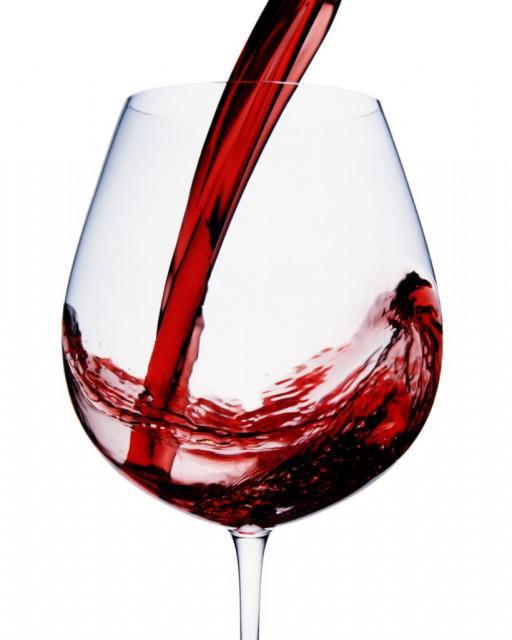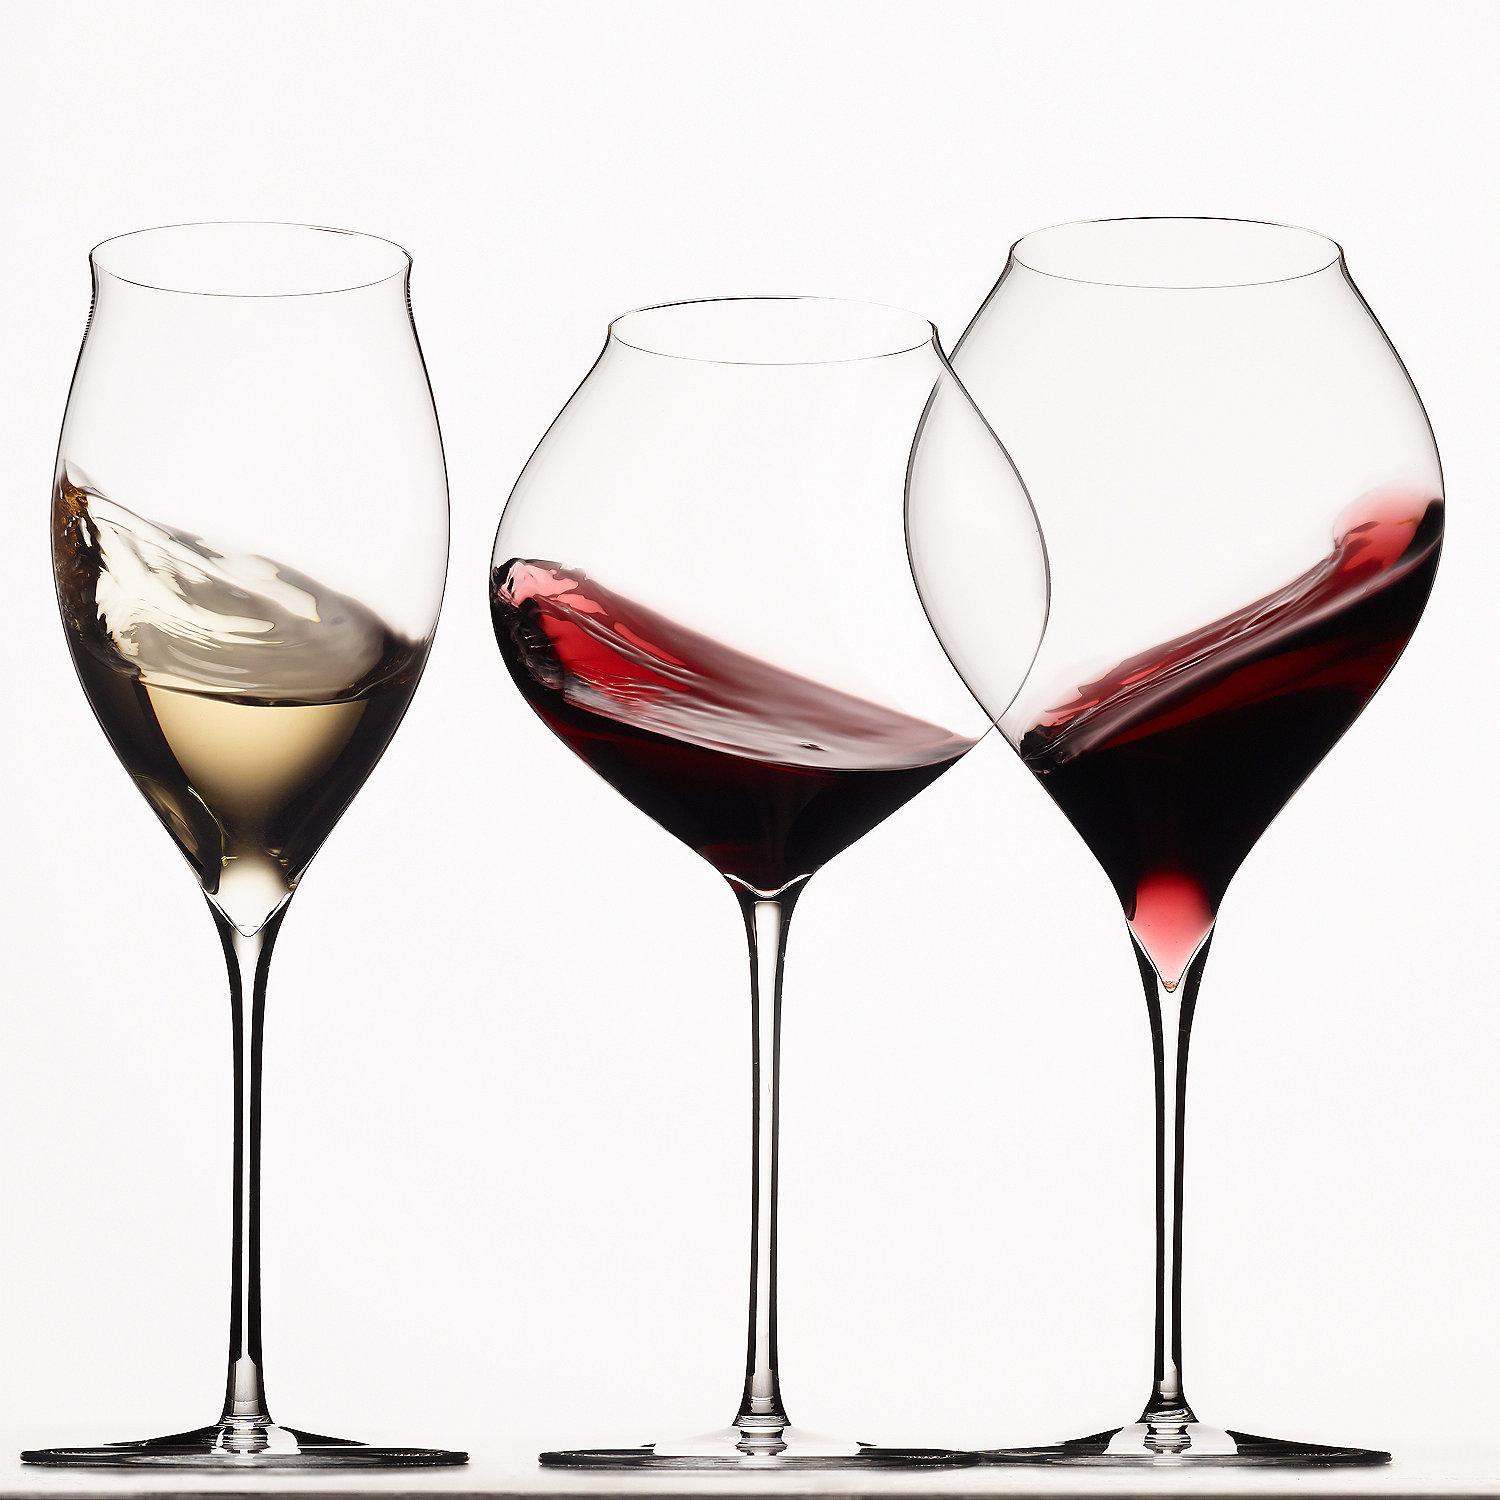The first image is the image on the left, the second image is the image on the right. Assess this claim about the two images: "At least one image has more than one wine glass in it.". Correct or not? Answer yes or no. Yes. 